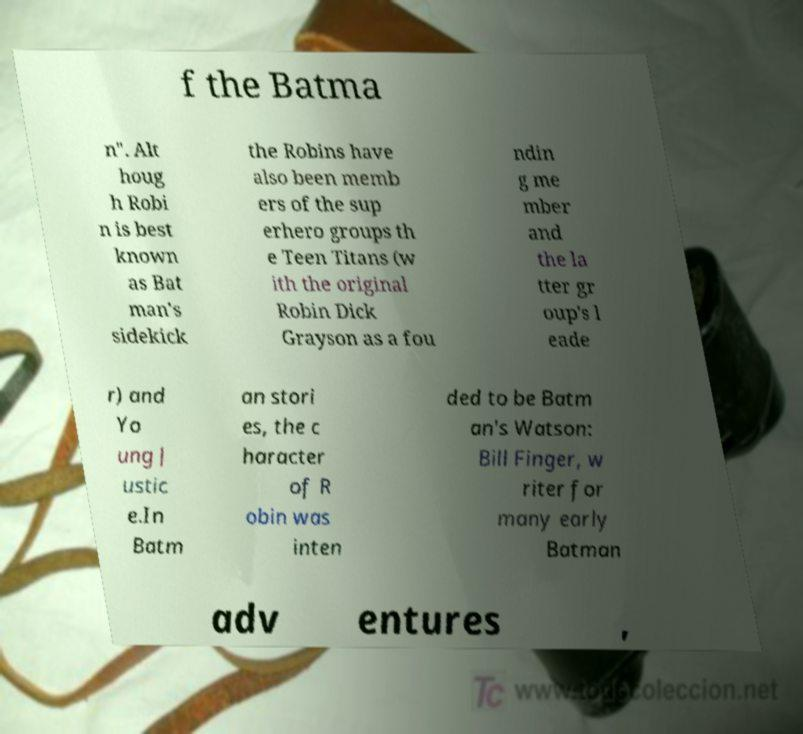Can you accurately transcribe the text from the provided image for me? f the Batma n". Alt houg h Robi n is best known as Bat man's sidekick the Robins have also been memb ers of the sup erhero groups th e Teen Titans (w ith the original Robin Dick Grayson as a fou ndin g me mber and the la tter gr oup's l eade r) and Yo ung J ustic e.In Batm an stori es, the c haracter of R obin was inten ded to be Batm an's Watson: Bill Finger, w riter for many early Batman adv entures , 